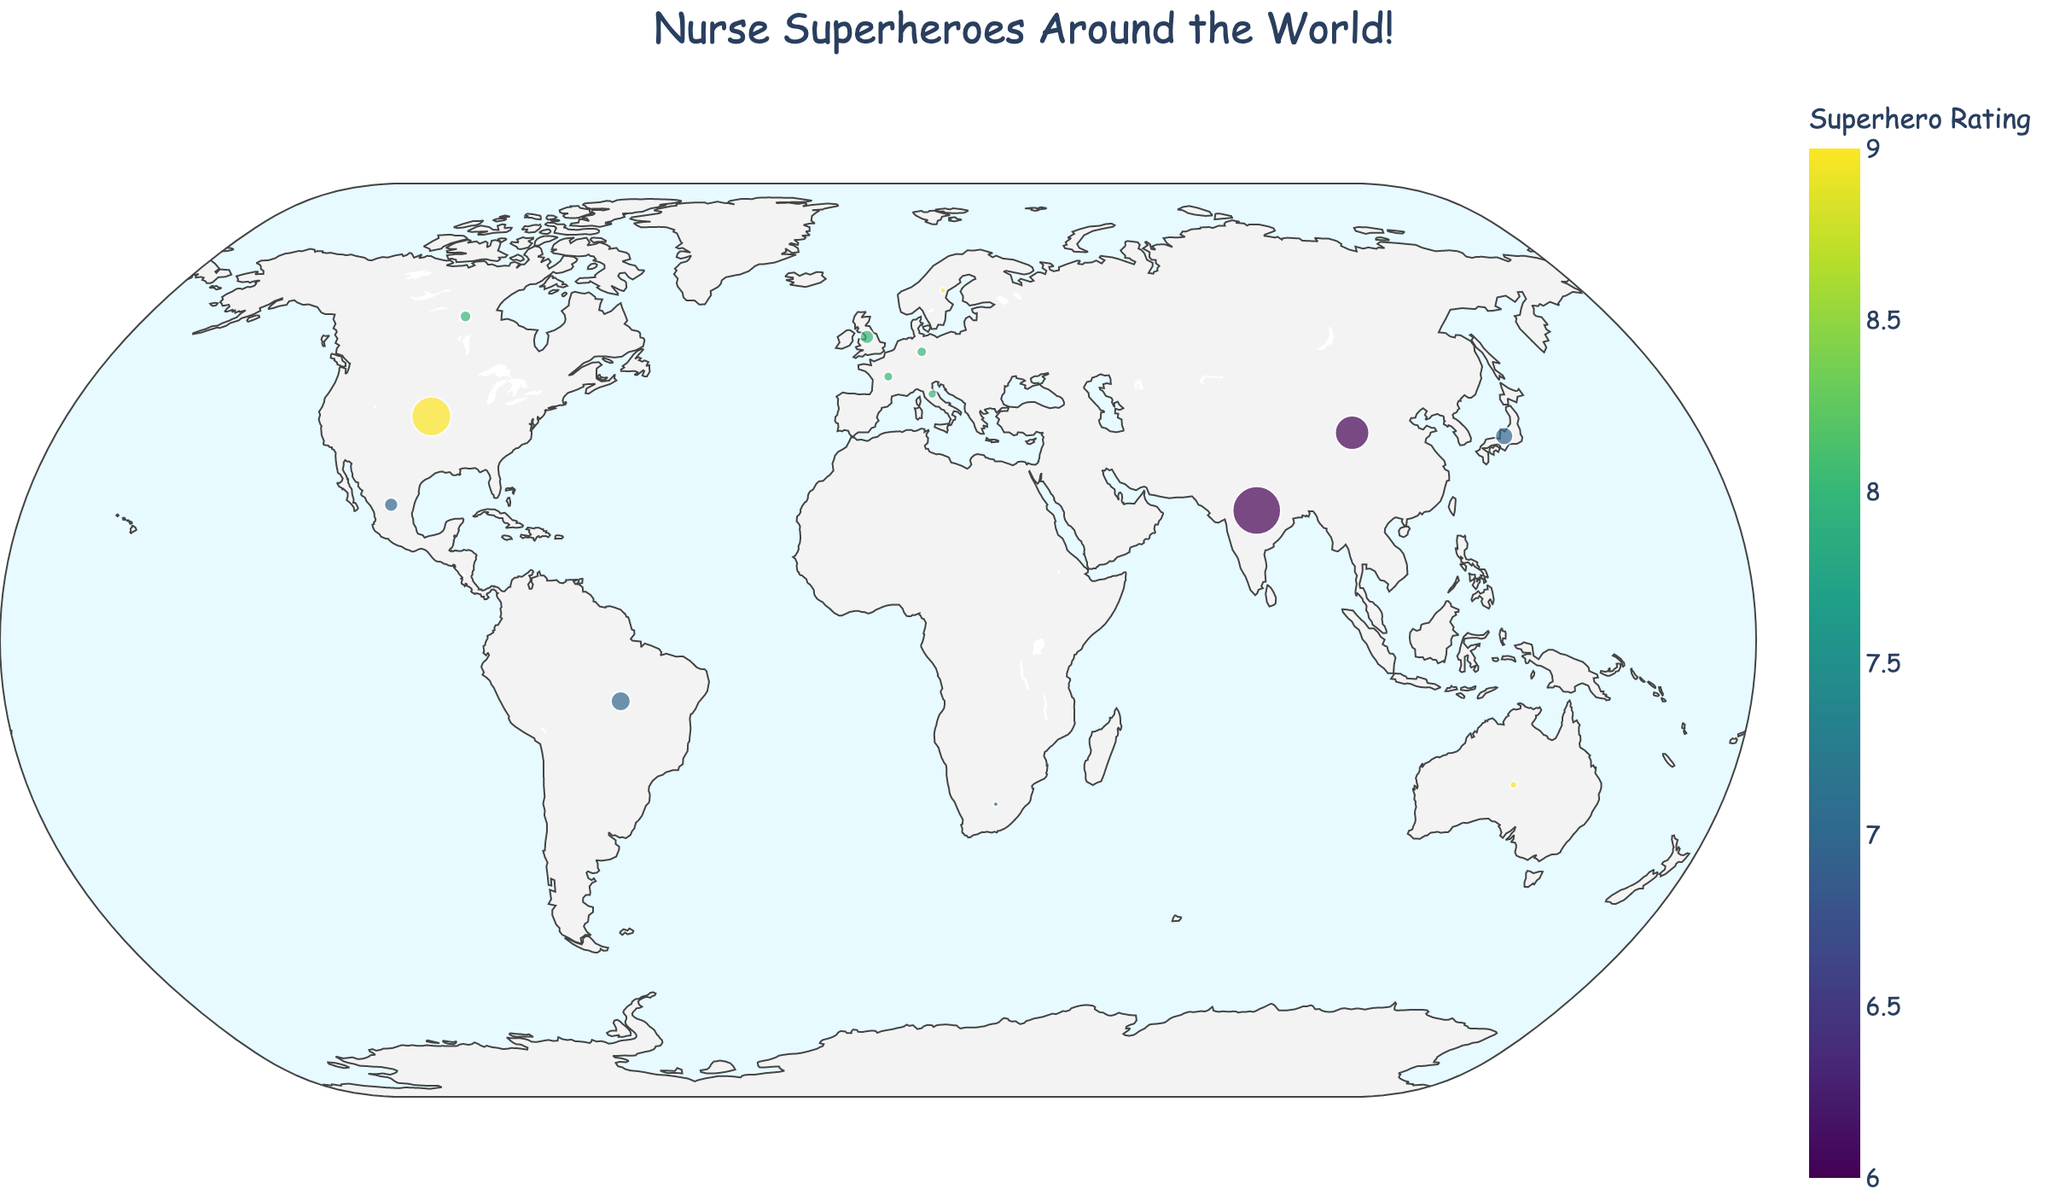Which country has the most nursing schools? By looking at the sizes of the bubbles on the map, the United States has the biggest bubble, indicating the most nursing schools.
Answer: United States Which region has the highest superhero rating on average? We need to sum the superhero ratings and divide by the number of countries in each region. North America: (9 + 8 + 7)/3 = 8. Oceania: (9 + 9)/2 = 9. Europe: (8 + 8 + 8 + 8 + 9)/5 = 8.2. Asia: (7 + 6 + 6)/3 = 6.3. South America: 7. Africa: 7. Therefore, Oceania has the highest average rating.
Answer: Oceania How many nurse training programs does Brazil have? By hovering over Brazil on the map, we can see the number of nurse training programs listed in the hover data.
Answer: 350 Which two countries have the same superhero rating but are in different regions? By looking at the color shades representing the superhero rating, we note that both Sweden (Europe) and New Zealand (Oceania) have a rating of 9.
Answer: Sweden and New Zealand Which country has the smallest number of nursing schools and what is its superhero rating? By comparing the sizes of the bubbles, New Zealand has the smallest bubble representing the fewest nursing schools. Its superhero rating is visible as well.
Answer: New Zealand, 9 